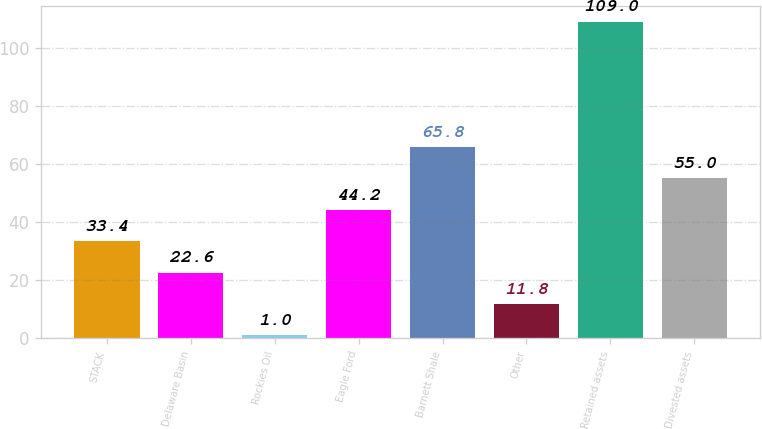Convert chart. <chart><loc_0><loc_0><loc_500><loc_500><bar_chart><fcel>STACK<fcel>Delaware Basin<fcel>Rockies Oil<fcel>Eagle Ford<fcel>Barnett Shale<fcel>Other<fcel>Retained assets<fcel>Divested assets<nl><fcel>33.4<fcel>22.6<fcel>1<fcel>44.2<fcel>65.8<fcel>11.8<fcel>109<fcel>55<nl></chart> 